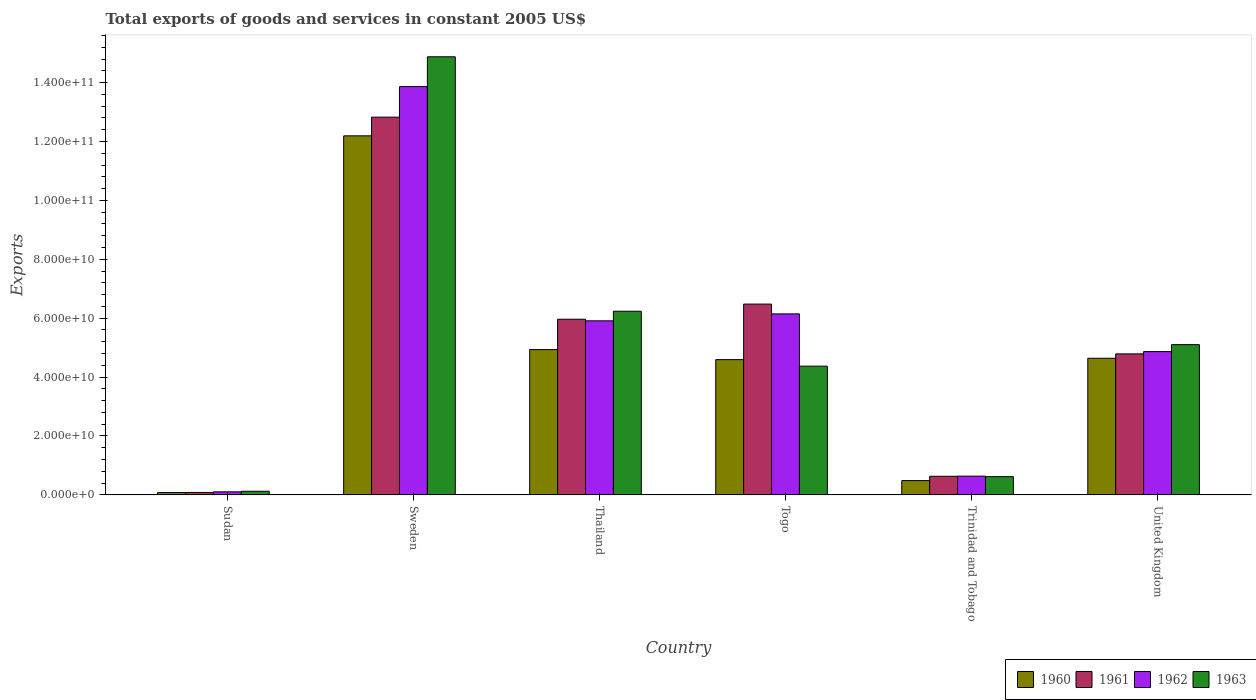How many different coloured bars are there?
Give a very brief answer. 4. Are the number of bars per tick equal to the number of legend labels?
Your answer should be compact. Yes. What is the label of the 5th group of bars from the left?
Your response must be concise. Trinidad and Tobago. What is the total exports of goods and services in 1962 in United Kingdom?
Provide a succinct answer. 4.87e+1. Across all countries, what is the maximum total exports of goods and services in 1962?
Provide a succinct answer. 1.39e+11. Across all countries, what is the minimum total exports of goods and services in 1961?
Ensure brevity in your answer.  8.33e+08. In which country was the total exports of goods and services in 1963 maximum?
Offer a very short reply. Sweden. In which country was the total exports of goods and services in 1963 minimum?
Keep it short and to the point. Sudan. What is the total total exports of goods and services in 1962 in the graph?
Give a very brief answer. 3.15e+11. What is the difference between the total exports of goods and services in 1962 in Thailand and that in Togo?
Your response must be concise. -2.36e+09. What is the difference between the total exports of goods and services in 1963 in Togo and the total exports of goods and services in 1960 in Trinidad and Tobago?
Your answer should be very brief. 3.88e+1. What is the average total exports of goods and services in 1963 per country?
Keep it short and to the point. 5.22e+1. What is the difference between the total exports of goods and services of/in 1963 and total exports of goods and services of/in 1961 in Togo?
Make the answer very short. -2.11e+1. What is the ratio of the total exports of goods and services in 1963 in Sudan to that in United Kingdom?
Your response must be concise. 0.02. Is the total exports of goods and services in 1962 in Thailand less than that in United Kingdom?
Your answer should be compact. No. Is the difference between the total exports of goods and services in 1963 in Thailand and Trinidad and Tobago greater than the difference between the total exports of goods and services in 1961 in Thailand and Trinidad and Tobago?
Your response must be concise. Yes. What is the difference between the highest and the second highest total exports of goods and services in 1960?
Offer a terse response. 2.95e+09. What is the difference between the highest and the lowest total exports of goods and services in 1963?
Give a very brief answer. 1.48e+11. In how many countries, is the total exports of goods and services in 1961 greater than the average total exports of goods and services in 1961 taken over all countries?
Provide a short and direct response. 3. Is the sum of the total exports of goods and services in 1961 in Thailand and Togo greater than the maximum total exports of goods and services in 1963 across all countries?
Your answer should be compact. No. Is it the case that in every country, the sum of the total exports of goods and services in 1961 and total exports of goods and services in 1960 is greater than the sum of total exports of goods and services in 1963 and total exports of goods and services in 1962?
Your answer should be very brief. No. What does the 1st bar from the left in United Kingdom represents?
Offer a very short reply. 1960. What does the 2nd bar from the right in Trinidad and Tobago represents?
Make the answer very short. 1962. How many bars are there?
Give a very brief answer. 24. Are all the bars in the graph horizontal?
Offer a very short reply. No. Does the graph contain any zero values?
Provide a short and direct response. No. Where does the legend appear in the graph?
Your answer should be very brief. Bottom right. How many legend labels are there?
Offer a terse response. 4. What is the title of the graph?
Provide a short and direct response. Total exports of goods and services in constant 2005 US$. What is the label or title of the X-axis?
Your response must be concise. Country. What is the label or title of the Y-axis?
Ensure brevity in your answer.  Exports. What is the Exports in 1960 in Sudan?
Your answer should be very brief. 8.03e+08. What is the Exports of 1961 in Sudan?
Your answer should be compact. 8.33e+08. What is the Exports in 1962 in Sudan?
Make the answer very short. 1.04e+09. What is the Exports of 1963 in Sudan?
Make the answer very short. 1.24e+09. What is the Exports in 1960 in Sweden?
Provide a succinct answer. 1.22e+11. What is the Exports of 1961 in Sweden?
Ensure brevity in your answer.  1.28e+11. What is the Exports in 1962 in Sweden?
Provide a succinct answer. 1.39e+11. What is the Exports in 1963 in Sweden?
Your answer should be very brief. 1.49e+11. What is the Exports of 1960 in Thailand?
Give a very brief answer. 4.93e+1. What is the Exports in 1961 in Thailand?
Give a very brief answer. 5.97e+1. What is the Exports in 1962 in Thailand?
Provide a short and direct response. 5.91e+1. What is the Exports of 1963 in Thailand?
Make the answer very short. 6.24e+1. What is the Exports in 1960 in Togo?
Ensure brevity in your answer.  4.59e+1. What is the Exports of 1961 in Togo?
Provide a succinct answer. 6.48e+1. What is the Exports of 1962 in Togo?
Your answer should be very brief. 6.15e+1. What is the Exports in 1963 in Togo?
Your answer should be compact. 4.37e+1. What is the Exports in 1960 in Trinidad and Tobago?
Provide a succinct answer. 4.86e+09. What is the Exports in 1961 in Trinidad and Tobago?
Your answer should be very brief. 6.32e+09. What is the Exports in 1962 in Trinidad and Tobago?
Your answer should be very brief. 6.37e+09. What is the Exports of 1963 in Trinidad and Tobago?
Ensure brevity in your answer.  6.20e+09. What is the Exports in 1960 in United Kingdom?
Provide a succinct answer. 4.64e+1. What is the Exports of 1961 in United Kingdom?
Provide a succinct answer. 4.79e+1. What is the Exports in 1962 in United Kingdom?
Offer a terse response. 4.87e+1. What is the Exports of 1963 in United Kingdom?
Provide a succinct answer. 5.10e+1. Across all countries, what is the maximum Exports of 1960?
Offer a very short reply. 1.22e+11. Across all countries, what is the maximum Exports of 1961?
Provide a succinct answer. 1.28e+11. Across all countries, what is the maximum Exports of 1962?
Your response must be concise. 1.39e+11. Across all countries, what is the maximum Exports of 1963?
Give a very brief answer. 1.49e+11. Across all countries, what is the minimum Exports in 1960?
Give a very brief answer. 8.03e+08. Across all countries, what is the minimum Exports of 1961?
Offer a terse response. 8.33e+08. Across all countries, what is the minimum Exports of 1962?
Offer a terse response. 1.04e+09. Across all countries, what is the minimum Exports of 1963?
Ensure brevity in your answer.  1.24e+09. What is the total Exports in 1960 in the graph?
Make the answer very short. 2.69e+11. What is the total Exports in 1961 in the graph?
Make the answer very short. 3.08e+11. What is the total Exports in 1962 in the graph?
Offer a terse response. 3.15e+11. What is the total Exports in 1963 in the graph?
Keep it short and to the point. 3.13e+11. What is the difference between the Exports of 1960 in Sudan and that in Sweden?
Your answer should be very brief. -1.21e+11. What is the difference between the Exports in 1961 in Sudan and that in Sweden?
Provide a succinct answer. -1.27e+11. What is the difference between the Exports in 1962 in Sudan and that in Sweden?
Your answer should be very brief. -1.38e+11. What is the difference between the Exports of 1963 in Sudan and that in Sweden?
Provide a short and direct response. -1.48e+11. What is the difference between the Exports in 1960 in Sudan and that in Thailand?
Your answer should be very brief. -4.85e+1. What is the difference between the Exports of 1961 in Sudan and that in Thailand?
Your answer should be very brief. -5.88e+1. What is the difference between the Exports in 1962 in Sudan and that in Thailand?
Your answer should be very brief. -5.81e+1. What is the difference between the Exports of 1963 in Sudan and that in Thailand?
Provide a succinct answer. -6.11e+1. What is the difference between the Exports in 1960 in Sudan and that in Togo?
Make the answer very short. -4.51e+1. What is the difference between the Exports of 1961 in Sudan and that in Togo?
Give a very brief answer. -6.40e+1. What is the difference between the Exports in 1962 in Sudan and that in Togo?
Your answer should be very brief. -6.04e+1. What is the difference between the Exports of 1963 in Sudan and that in Togo?
Offer a very short reply. -4.25e+1. What is the difference between the Exports in 1960 in Sudan and that in Trinidad and Tobago?
Give a very brief answer. -4.06e+09. What is the difference between the Exports in 1961 in Sudan and that in Trinidad and Tobago?
Provide a succinct answer. -5.49e+09. What is the difference between the Exports of 1962 in Sudan and that in Trinidad and Tobago?
Offer a very short reply. -5.33e+09. What is the difference between the Exports of 1963 in Sudan and that in Trinidad and Tobago?
Your answer should be very brief. -4.97e+09. What is the difference between the Exports in 1960 in Sudan and that in United Kingdom?
Your answer should be compact. -4.56e+1. What is the difference between the Exports of 1961 in Sudan and that in United Kingdom?
Provide a succinct answer. -4.71e+1. What is the difference between the Exports of 1962 in Sudan and that in United Kingdom?
Provide a short and direct response. -4.76e+1. What is the difference between the Exports of 1963 in Sudan and that in United Kingdom?
Your answer should be very brief. -4.98e+1. What is the difference between the Exports in 1960 in Sweden and that in Thailand?
Keep it short and to the point. 7.26e+1. What is the difference between the Exports of 1961 in Sweden and that in Thailand?
Provide a succinct answer. 6.86e+1. What is the difference between the Exports in 1962 in Sweden and that in Thailand?
Make the answer very short. 7.95e+1. What is the difference between the Exports in 1963 in Sweden and that in Thailand?
Your answer should be very brief. 8.64e+1. What is the difference between the Exports in 1960 in Sweden and that in Togo?
Your answer should be compact. 7.60e+1. What is the difference between the Exports of 1961 in Sweden and that in Togo?
Ensure brevity in your answer.  6.35e+1. What is the difference between the Exports in 1962 in Sweden and that in Togo?
Provide a short and direct response. 7.72e+1. What is the difference between the Exports of 1963 in Sweden and that in Togo?
Your answer should be very brief. 1.05e+11. What is the difference between the Exports in 1960 in Sweden and that in Trinidad and Tobago?
Provide a succinct answer. 1.17e+11. What is the difference between the Exports in 1961 in Sweden and that in Trinidad and Tobago?
Make the answer very short. 1.22e+11. What is the difference between the Exports of 1962 in Sweden and that in Trinidad and Tobago?
Offer a terse response. 1.32e+11. What is the difference between the Exports in 1963 in Sweden and that in Trinidad and Tobago?
Give a very brief answer. 1.43e+11. What is the difference between the Exports in 1960 in Sweden and that in United Kingdom?
Offer a very short reply. 7.55e+1. What is the difference between the Exports of 1961 in Sweden and that in United Kingdom?
Give a very brief answer. 8.04e+1. What is the difference between the Exports of 1962 in Sweden and that in United Kingdom?
Your response must be concise. 9.00e+1. What is the difference between the Exports of 1963 in Sweden and that in United Kingdom?
Offer a very short reply. 9.77e+1. What is the difference between the Exports of 1960 in Thailand and that in Togo?
Give a very brief answer. 3.42e+09. What is the difference between the Exports of 1961 in Thailand and that in Togo?
Give a very brief answer. -5.14e+09. What is the difference between the Exports in 1962 in Thailand and that in Togo?
Your response must be concise. -2.36e+09. What is the difference between the Exports in 1963 in Thailand and that in Togo?
Provide a short and direct response. 1.87e+1. What is the difference between the Exports in 1960 in Thailand and that in Trinidad and Tobago?
Give a very brief answer. 4.45e+1. What is the difference between the Exports in 1961 in Thailand and that in Trinidad and Tobago?
Your answer should be compact. 5.33e+1. What is the difference between the Exports of 1962 in Thailand and that in Trinidad and Tobago?
Provide a short and direct response. 5.27e+1. What is the difference between the Exports of 1963 in Thailand and that in Trinidad and Tobago?
Provide a short and direct response. 5.62e+1. What is the difference between the Exports in 1960 in Thailand and that in United Kingdom?
Ensure brevity in your answer.  2.95e+09. What is the difference between the Exports of 1961 in Thailand and that in United Kingdom?
Keep it short and to the point. 1.18e+1. What is the difference between the Exports of 1962 in Thailand and that in United Kingdom?
Offer a very short reply. 1.04e+1. What is the difference between the Exports in 1963 in Thailand and that in United Kingdom?
Give a very brief answer. 1.13e+1. What is the difference between the Exports in 1960 in Togo and that in Trinidad and Tobago?
Offer a terse response. 4.11e+1. What is the difference between the Exports in 1961 in Togo and that in Trinidad and Tobago?
Ensure brevity in your answer.  5.85e+1. What is the difference between the Exports of 1962 in Togo and that in Trinidad and Tobago?
Your answer should be compact. 5.51e+1. What is the difference between the Exports in 1963 in Togo and that in Trinidad and Tobago?
Give a very brief answer. 3.75e+1. What is the difference between the Exports in 1960 in Togo and that in United Kingdom?
Your answer should be very brief. -4.64e+08. What is the difference between the Exports of 1961 in Togo and that in United Kingdom?
Your answer should be compact. 1.69e+1. What is the difference between the Exports of 1962 in Togo and that in United Kingdom?
Provide a short and direct response. 1.28e+1. What is the difference between the Exports in 1963 in Togo and that in United Kingdom?
Provide a succinct answer. -7.31e+09. What is the difference between the Exports of 1960 in Trinidad and Tobago and that in United Kingdom?
Give a very brief answer. -4.15e+1. What is the difference between the Exports in 1961 in Trinidad and Tobago and that in United Kingdom?
Provide a succinct answer. -4.16e+1. What is the difference between the Exports in 1962 in Trinidad and Tobago and that in United Kingdom?
Ensure brevity in your answer.  -4.23e+1. What is the difference between the Exports of 1963 in Trinidad and Tobago and that in United Kingdom?
Offer a very short reply. -4.48e+1. What is the difference between the Exports in 1960 in Sudan and the Exports in 1961 in Sweden?
Your answer should be compact. -1.27e+11. What is the difference between the Exports in 1960 in Sudan and the Exports in 1962 in Sweden?
Give a very brief answer. -1.38e+11. What is the difference between the Exports of 1960 in Sudan and the Exports of 1963 in Sweden?
Give a very brief answer. -1.48e+11. What is the difference between the Exports in 1961 in Sudan and the Exports in 1962 in Sweden?
Your answer should be compact. -1.38e+11. What is the difference between the Exports in 1961 in Sudan and the Exports in 1963 in Sweden?
Ensure brevity in your answer.  -1.48e+11. What is the difference between the Exports of 1962 in Sudan and the Exports of 1963 in Sweden?
Your response must be concise. -1.48e+11. What is the difference between the Exports in 1960 in Sudan and the Exports in 1961 in Thailand?
Your answer should be compact. -5.88e+1. What is the difference between the Exports of 1960 in Sudan and the Exports of 1962 in Thailand?
Provide a succinct answer. -5.83e+1. What is the difference between the Exports of 1960 in Sudan and the Exports of 1963 in Thailand?
Your answer should be very brief. -6.16e+1. What is the difference between the Exports of 1961 in Sudan and the Exports of 1962 in Thailand?
Give a very brief answer. -5.83e+1. What is the difference between the Exports of 1961 in Sudan and the Exports of 1963 in Thailand?
Offer a terse response. -6.15e+1. What is the difference between the Exports of 1962 in Sudan and the Exports of 1963 in Thailand?
Make the answer very short. -6.13e+1. What is the difference between the Exports of 1960 in Sudan and the Exports of 1961 in Togo?
Your answer should be compact. -6.40e+1. What is the difference between the Exports of 1960 in Sudan and the Exports of 1962 in Togo?
Offer a terse response. -6.07e+1. What is the difference between the Exports in 1960 in Sudan and the Exports in 1963 in Togo?
Your answer should be very brief. -4.29e+1. What is the difference between the Exports of 1961 in Sudan and the Exports of 1962 in Togo?
Provide a short and direct response. -6.06e+1. What is the difference between the Exports of 1961 in Sudan and the Exports of 1963 in Togo?
Provide a succinct answer. -4.29e+1. What is the difference between the Exports in 1962 in Sudan and the Exports in 1963 in Togo?
Keep it short and to the point. -4.27e+1. What is the difference between the Exports of 1960 in Sudan and the Exports of 1961 in Trinidad and Tobago?
Ensure brevity in your answer.  -5.52e+09. What is the difference between the Exports in 1960 in Sudan and the Exports in 1962 in Trinidad and Tobago?
Give a very brief answer. -5.57e+09. What is the difference between the Exports of 1960 in Sudan and the Exports of 1963 in Trinidad and Tobago?
Keep it short and to the point. -5.40e+09. What is the difference between the Exports of 1961 in Sudan and the Exports of 1962 in Trinidad and Tobago?
Provide a short and direct response. -5.54e+09. What is the difference between the Exports of 1961 in Sudan and the Exports of 1963 in Trinidad and Tobago?
Offer a terse response. -5.37e+09. What is the difference between the Exports in 1962 in Sudan and the Exports in 1963 in Trinidad and Tobago?
Give a very brief answer. -5.16e+09. What is the difference between the Exports in 1960 in Sudan and the Exports in 1961 in United Kingdom?
Offer a very short reply. -4.71e+1. What is the difference between the Exports of 1960 in Sudan and the Exports of 1962 in United Kingdom?
Ensure brevity in your answer.  -4.79e+1. What is the difference between the Exports in 1960 in Sudan and the Exports in 1963 in United Kingdom?
Offer a very short reply. -5.02e+1. What is the difference between the Exports of 1961 in Sudan and the Exports of 1962 in United Kingdom?
Ensure brevity in your answer.  -4.78e+1. What is the difference between the Exports in 1961 in Sudan and the Exports in 1963 in United Kingdom?
Offer a very short reply. -5.02e+1. What is the difference between the Exports of 1962 in Sudan and the Exports of 1963 in United Kingdom?
Your answer should be compact. -5.00e+1. What is the difference between the Exports of 1960 in Sweden and the Exports of 1961 in Thailand?
Make the answer very short. 6.23e+1. What is the difference between the Exports of 1960 in Sweden and the Exports of 1962 in Thailand?
Offer a terse response. 6.28e+1. What is the difference between the Exports of 1960 in Sweden and the Exports of 1963 in Thailand?
Provide a succinct answer. 5.96e+1. What is the difference between the Exports of 1961 in Sweden and the Exports of 1962 in Thailand?
Make the answer very short. 6.92e+1. What is the difference between the Exports of 1961 in Sweden and the Exports of 1963 in Thailand?
Give a very brief answer. 6.59e+1. What is the difference between the Exports in 1962 in Sweden and the Exports in 1963 in Thailand?
Keep it short and to the point. 7.63e+1. What is the difference between the Exports of 1960 in Sweden and the Exports of 1961 in Togo?
Offer a very short reply. 5.71e+1. What is the difference between the Exports in 1960 in Sweden and the Exports in 1962 in Togo?
Your response must be concise. 6.05e+1. What is the difference between the Exports in 1960 in Sweden and the Exports in 1963 in Togo?
Ensure brevity in your answer.  7.82e+1. What is the difference between the Exports of 1961 in Sweden and the Exports of 1962 in Togo?
Your response must be concise. 6.68e+1. What is the difference between the Exports of 1961 in Sweden and the Exports of 1963 in Togo?
Offer a very short reply. 8.46e+1. What is the difference between the Exports in 1962 in Sweden and the Exports in 1963 in Togo?
Make the answer very short. 9.49e+1. What is the difference between the Exports in 1960 in Sweden and the Exports in 1961 in Trinidad and Tobago?
Provide a short and direct response. 1.16e+11. What is the difference between the Exports of 1960 in Sweden and the Exports of 1962 in Trinidad and Tobago?
Your response must be concise. 1.16e+11. What is the difference between the Exports in 1960 in Sweden and the Exports in 1963 in Trinidad and Tobago?
Offer a terse response. 1.16e+11. What is the difference between the Exports in 1961 in Sweden and the Exports in 1962 in Trinidad and Tobago?
Your response must be concise. 1.22e+11. What is the difference between the Exports of 1961 in Sweden and the Exports of 1963 in Trinidad and Tobago?
Offer a terse response. 1.22e+11. What is the difference between the Exports of 1962 in Sweden and the Exports of 1963 in Trinidad and Tobago?
Offer a terse response. 1.32e+11. What is the difference between the Exports of 1960 in Sweden and the Exports of 1961 in United Kingdom?
Your answer should be compact. 7.40e+1. What is the difference between the Exports of 1960 in Sweden and the Exports of 1962 in United Kingdom?
Offer a very short reply. 7.33e+1. What is the difference between the Exports of 1960 in Sweden and the Exports of 1963 in United Kingdom?
Provide a short and direct response. 7.09e+1. What is the difference between the Exports of 1961 in Sweden and the Exports of 1962 in United Kingdom?
Give a very brief answer. 7.96e+1. What is the difference between the Exports in 1961 in Sweden and the Exports in 1963 in United Kingdom?
Give a very brief answer. 7.72e+1. What is the difference between the Exports in 1962 in Sweden and the Exports in 1963 in United Kingdom?
Ensure brevity in your answer.  8.76e+1. What is the difference between the Exports of 1960 in Thailand and the Exports of 1961 in Togo?
Provide a succinct answer. -1.54e+1. What is the difference between the Exports of 1960 in Thailand and the Exports of 1962 in Togo?
Your response must be concise. -1.21e+1. What is the difference between the Exports in 1960 in Thailand and the Exports in 1963 in Togo?
Give a very brief answer. 5.64e+09. What is the difference between the Exports in 1961 in Thailand and the Exports in 1962 in Togo?
Keep it short and to the point. -1.81e+09. What is the difference between the Exports in 1961 in Thailand and the Exports in 1963 in Togo?
Give a very brief answer. 1.59e+1. What is the difference between the Exports in 1962 in Thailand and the Exports in 1963 in Togo?
Keep it short and to the point. 1.54e+1. What is the difference between the Exports of 1960 in Thailand and the Exports of 1961 in Trinidad and Tobago?
Your answer should be very brief. 4.30e+1. What is the difference between the Exports in 1960 in Thailand and the Exports in 1962 in Trinidad and Tobago?
Your response must be concise. 4.30e+1. What is the difference between the Exports in 1960 in Thailand and the Exports in 1963 in Trinidad and Tobago?
Offer a terse response. 4.31e+1. What is the difference between the Exports in 1961 in Thailand and the Exports in 1962 in Trinidad and Tobago?
Your response must be concise. 5.33e+1. What is the difference between the Exports of 1961 in Thailand and the Exports of 1963 in Trinidad and Tobago?
Offer a very short reply. 5.34e+1. What is the difference between the Exports in 1962 in Thailand and the Exports in 1963 in Trinidad and Tobago?
Provide a short and direct response. 5.29e+1. What is the difference between the Exports in 1960 in Thailand and the Exports in 1961 in United Kingdom?
Offer a very short reply. 1.46e+09. What is the difference between the Exports in 1960 in Thailand and the Exports in 1962 in United Kingdom?
Your answer should be very brief. 6.85e+08. What is the difference between the Exports in 1960 in Thailand and the Exports in 1963 in United Kingdom?
Your response must be concise. -1.67e+09. What is the difference between the Exports in 1961 in Thailand and the Exports in 1962 in United Kingdom?
Provide a succinct answer. 1.10e+1. What is the difference between the Exports of 1961 in Thailand and the Exports of 1963 in United Kingdom?
Ensure brevity in your answer.  8.63e+09. What is the difference between the Exports in 1962 in Thailand and the Exports in 1963 in United Kingdom?
Offer a very short reply. 8.09e+09. What is the difference between the Exports of 1960 in Togo and the Exports of 1961 in Trinidad and Tobago?
Provide a succinct answer. 3.96e+1. What is the difference between the Exports in 1960 in Togo and the Exports in 1962 in Trinidad and Tobago?
Ensure brevity in your answer.  3.96e+1. What is the difference between the Exports in 1960 in Togo and the Exports in 1963 in Trinidad and Tobago?
Ensure brevity in your answer.  3.97e+1. What is the difference between the Exports of 1961 in Togo and the Exports of 1962 in Trinidad and Tobago?
Your response must be concise. 5.84e+1. What is the difference between the Exports in 1961 in Togo and the Exports in 1963 in Trinidad and Tobago?
Give a very brief answer. 5.86e+1. What is the difference between the Exports of 1962 in Togo and the Exports of 1963 in Trinidad and Tobago?
Ensure brevity in your answer.  5.53e+1. What is the difference between the Exports in 1960 in Togo and the Exports in 1961 in United Kingdom?
Your answer should be very brief. -1.96e+09. What is the difference between the Exports in 1960 in Togo and the Exports in 1962 in United Kingdom?
Keep it short and to the point. -2.73e+09. What is the difference between the Exports of 1960 in Togo and the Exports of 1963 in United Kingdom?
Provide a short and direct response. -5.09e+09. What is the difference between the Exports in 1961 in Togo and the Exports in 1962 in United Kingdom?
Provide a short and direct response. 1.61e+1. What is the difference between the Exports in 1961 in Togo and the Exports in 1963 in United Kingdom?
Make the answer very short. 1.38e+1. What is the difference between the Exports in 1962 in Togo and the Exports in 1963 in United Kingdom?
Your answer should be very brief. 1.04e+1. What is the difference between the Exports in 1960 in Trinidad and Tobago and the Exports in 1961 in United Kingdom?
Your answer should be compact. -4.30e+1. What is the difference between the Exports of 1960 in Trinidad and Tobago and the Exports of 1962 in United Kingdom?
Your answer should be compact. -4.38e+1. What is the difference between the Exports in 1960 in Trinidad and Tobago and the Exports in 1963 in United Kingdom?
Provide a short and direct response. -4.62e+1. What is the difference between the Exports in 1961 in Trinidad and Tobago and the Exports in 1962 in United Kingdom?
Provide a short and direct response. -4.23e+1. What is the difference between the Exports of 1961 in Trinidad and Tobago and the Exports of 1963 in United Kingdom?
Offer a terse response. -4.47e+1. What is the difference between the Exports of 1962 in Trinidad and Tobago and the Exports of 1963 in United Kingdom?
Give a very brief answer. -4.47e+1. What is the average Exports in 1960 per country?
Offer a very short reply. 4.49e+1. What is the average Exports in 1961 per country?
Give a very brief answer. 5.13e+1. What is the average Exports of 1962 per country?
Ensure brevity in your answer.  5.25e+1. What is the average Exports of 1963 per country?
Provide a short and direct response. 5.22e+1. What is the difference between the Exports in 1960 and Exports in 1961 in Sudan?
Keep it short and to the point. -3.01e+07. What is the difference between the Exports in 1960 and Exports in 1962 in Sudan?
Make the answer very short. -2.41e+08. What is the difference between the Exports of 1960 and Exports of 1963 in Sudan?
Your answer should be very brief. -4.34e+08. What is the difference between the Exports in 1961 and Exports in 1962 in Sudan?
Your answer should be compact. -2.11e+08. What is the difference between the Exports of 1961 and Exports of 1963 in Sudan?
Make the answer very short. -4.04e+08. What is the difference between the Exports in 1962 and Exports in 1963 in Sudan?
Give a very brief answer. -1.93e+08. What is the difference between the Exports of 1960 and Exports of 1961 in Sweden?
Your answer should be compact. -6.34e+09. What is the difference between the Exports in 1960 and Exports in 1962 in Sweden?
Your response must be concise. -1.67e+1. What is the difference between the Exports in 1960 and Exports in 1963 in Sweden?
Keep it short and to the point. -2.68e+1. What is the difference between the Exports in 1961 and Exports in 1962 in Sweden?
Your response must be concise. -1.04e+1. What is the difference between the Exports in 1961 and Exports in 1963 in Sweden?
Offer a terse response. -2.05e+1. What is the difference between the Exports of 1962 and Exports of 1963 in Sweden?
Your answer should be very brief. -1.01e+1. What is the difference between the Exports of 1960 and Exports of 1961 in Thailand?
Your response must be concise. -1.03e+1. What is the difference between the Exports in 1960 and Exports in 1962 in Thailand?
Provide a short and direct response. -9.76e+09. What is the difference between the Exports in 1960 and Exports in 1963 in Thailand?
Offer a terse response. -1.30e+1. What is the difference between the Exports in 1961 and Exports in 1962 in Thailand?
Provide a short and direct response. 5.43e+08. What is the difference between the Exports in 1961 and Exports in 1963 in Thailand?
Offer a terse response. -2.71e+09. What is the difference between the Exports of 1962 and Exports of 1963 in Thailand?
Your response must be concise. -3.25e+09. What is the difference between the Exports of 1960 and Exports of 1961 in Togo?
Offer a terse response. -1.89e+1. What is the difference between the Exports in 1960 and Exports in 1962 in Togo?
Offer a terse response. -1.55e+1. What is the difference between the Exports of 1960 and Exports of 1963 in Togo?
Make the answer very short. 2.22e+09. What is the difference between the Exports of 1961 and Exports of 1962 in Togo?
Offer a very short reply. 3.33e+09. What is the difference between the Exports of 1961 and Exports of 1963 in Togo?
Your answer should be very brief. 2.11e+1. What is the difference between the Exports of 1962 and Exports of 1963 in Togo?
Provide a succinct answer. 1.78e+1. What is the difference between the Exports in 1960 and Exports in 1961 in Trinidad and Tobago?
Offer a terse response. -1.46e+09. What is the difference between the Exports in 1960 and Exports in 1962 in Trinidad and Tobago?
Offer a terse response. -1.51e+09. What is the difference between the Exports of 1960 and Exports of 1963 in Trinidad and Tobago?
Offer a terse response. -1.34e+09. What is the difference between the Exports of 1961 and Exports of 1962 in Trinidad and Tobago?
Your answer should be very brief. -4.56e+07. What is the difference between the Exports of 1961 and Exports of 1963 in Trinidad and Tobago?
Your answer should be very brief. 1.22e+08. What is the difference between the Exports in 1962 and Exports in 1963 in Trinidad and Tobago?
Offer a terse response. 1.67e+08. What is the difference between the Exports in 1960 and Exports in 1961 in United Kingdom?
Provide a short and direct response. -1.49e+09. What is the difference between the Exports of 1960 and Exports of 1962 in United Kingdom?
Offer a very short reply. -2.27e+09. What is the difference between the Exports in 1960 and Exports in 1963 in United Kingdom?
Offer a terse response. -4.63e+09. What is the difference between the Exports of 1961 and Exports of 1962 in United Kingdom?
Offer a terse response. -7.73e+08. What is the difference between the Exports in 1961 and Exports in 1963 in United Kingdom?
Provide a short and direct response. -3.13e+09. What is the difference between the Exports of 1962 and Exports of 1963 in United Kingdom?
Provide a succinct answer. -2.36e+09. What is the ratio of the Exports of 1960 in Sudan to that in Sweden?
Your response must be concise. 0.01. What is the ratio of the Exports of 1961 in Sudan to that in Sweden?
Provide a succinct answer. 0.01. What is the ratio of the Exports in 1962 in Sudan to that in Sweden?
Your response must be concise. 0.01. What is the ratio of the Exports in 1963 in Sudan to that in Sweden?
Provide a short and direct response. 0.01. What is the ratio of the Exports in 1960 in Sudan to that in Thailand?
Offer a terse response. 0.02. What is the ratio of the Exports in 1961 in Sudan to that in Thailand?
Your answer should be very brief. 0.01. What is the ratio of the Exports in 1962 in Sudan to that in Thailand?
Your answer should be compact. 0.02. What is the ratio of the Exports in 1963 in Sudan to that in Thailand?
Give a very brief answer. 0.02. What is the ratio of the Exports of 1960 in Sudan to that in Togo?
Your response must be concise. 0.02. What is the ratio of the Exports of 1961 in Sudan to that in Togo?
Offer a terse response. 0.01. What is the ratio of the Exports of 1962 in Sudan to that in Togo?
Your answer should be very brief. 0.02. What is the ratio of the Exports in 1963 in Sudan to that in Togo?
Your answer should be very brief. 0.03. What is the ratio of the Exports in 1960 in Sudan to that in Trinidad and Tobago?
Ensure brevity in your answer.  0.17. What is the ratio of the Exports in 1961 in Sudan to that in Trinidad and Tobago?
Offer a terse response. 0.13. What is the ratio of the Exports in 1962 in Sudan to that in Trinidad and Tobago?
Offer a terse response. 0.16. What is the ratio of the Exports in 1963 in Sudan to that in Trinidad and Tobago?
Provide a short and direct response. 0.2. What is the ratio of the Exports of 1960 in Sudan to that in United Kingdom?
Give a very brief answer. 0.02. What is the ratio of the Exports in 1961 in Sudan to that in United Kingdom?
Your answer should be very brief. 0.02. What is the ratio of the Exports in 1962 in Sudan to that in United Kingdom?
Offer a terse response. 0.02. What is the ratio of the Exports in 1963 in Sudan to that in United Kingdom?
Your response must be concise. 0.02. What is the ratio of the Exports in 1960 in Sweden to that in Thailand?
Provide a succinct answer. 2.47. What is the ratio of the Exports of 1961 in Sweden to that in Thailand?
Give a very brief answer. 2.15. What is the ratio of the Exports of 1962 in Sweden to that in Thailand?
Make the answer very short. 2.35. What is the ratio of the Exports in 1963 in Sweden to that in Thailand?
Offer a terse response. 2.39. What is the ratio of the Exports of 1960 in Sweden to that in Togo?
Make the answer very short. 2.65. What is the ratio of the Exports in 1961 in Sweden to that in Togo?
Make the answer very short. 1.98. What is the ratio of the Exports in 1962 in Sweden to that in Togo?
Your response must be concise. 2.26. What is the ratio of the Exports of 1963 in Sweden to that in Togo?
Provide a short and direct response. 3.4. What is the ratio of the Exports of 1960 in Sweden to that in Trinidad and Tobago?
Your response must be concise. 25.06. What is the ratio of the Exports in 1961 in Sweden to that in Trinidad and Tobago?
Give a very brief answer. 20.28. What is the ratio of the Exports of 1962 in Sweden to that in Trinidad and Tobago?
Your answer should be very brief. 21.77. What is the ratio of the Exports of 1963 in Sweden to that in Trinidad and Tobago?
Your response must be concise. 23.98. What is the ratio of the Exports in 1960 in Sweden to that in United Kingdom?
Your answer should be compact. 2.63. What is the ratio of the Exports in 1961 in Sweden to that in United Kingdom?
Provide a succinct answer. 2.68. What is the ratio of the Exports in 1962 in Sweden to that in United Kingdom?
Offer a terse response. 2.85. What is the ratio of the Exports in 1963 in Sweden to that in United Kingdom?
Keep it short and to the point. 2.92. What is the ratio of the Exports in 1960 in Thailand to that in Togo?
Your answer should be compact. 1.07. What is the ratio of the Exports of 1961 in Thailand to that in Togo?
Make the answer very short. 0.92. What is the ratio of the Exports of 1962 in Thailand to that in Togo?
Give a very brief answer. 0.96. What is the ratio of the Exports in 1963 in Thailand to that in Togo?
Offer a very short reply. 1.43. What is the ratio of the Exports in 1960 in Thailand to that in Trinidad and Tobago?
Your response must be concise. 10.14. What is the ratio of the Exports of 1961 in Thailand to that in Trinidad and Tobago?
Your answer should be very brief. 9.43. What is the ratio of the Exports of 1962 in Thailand to that in Trinidad and Tobago?
Make the answer very short. 9.28. What is the ratio of the Exports in 1963 in Thailand to that in Trinidad and Tobago?
Keep it short and to the point. 10.05. What is the ratio of the Exports of 1960 in Thailand to that in United Kingdom?
Keep it short and to the point. 1.06. What is the ratio of the Exports of 1961 in Thailand to that in United Kingdom?
Your response must be concise. 1.25. What is the ratio of the Exports in 1962 in Thailand to that in United Kingdom?
Ensure brevity in your answer.  1.21. What is the ratio of the Exports in 1963 in Thailand to that in United Kingdom?
Ensure brevity in your answer.  1.22. What is the ratio of the Exports of 1960 in Togo to that in Trinidad and Tobago?
Provide a succinct answer. 9.44. What is the ratio of the Exports of 1961 in Togo to that in Trinidad and Tobago?
Your answer should be compact. 10.25. What is the ratio of the Exports in 1962 in Togo to that in Trinidad and Tobago?
Your answer should be compact. 9.65. What is the ratio of the Exports of 1963 in Togo to that in Trinidad and Tobago?
Your answer should be compact. 7.05. What is the ratio of the Exports in 1961 in Togo to that in United Kingdom?
Give a very brief answer. 1.35. What is the ratio of the Exports of 1962 in Togo to that in United Kingdom?
Give a very brief answer. 1.26. What is the ratio of the Exports in 1963 in Togo to that in United Kingdom?
Make the answer very short. 0.86. What is the ratio of the Exports of 1960 in Trinidad and Tobago to that in United Kingdom?
Your answer should be compact. 0.1. What is the ratio of the Exports in 1961 in Trinidad and Tobago to that in United Kingdom?
Provide a short and direct response. 0.13. What is the ratio of the Exports of 1962 in Trinidad and Tobago to that in United Kingdom?
Provide a short and direct response. 0.13. What is the ratio of the Exports of 1963 in Trinidad and Tobago to that in United Kingdom?
Keep it short and to the point. 0.12. What is the difference between the highest and the second highest Exports in 1960?
Provide a short and direct response. 7.26e+1. What is the difference between the highest and the second highest Exports in 1961?
Ensure brevity in your answer.  6.35e+1. What is the difference between the highest and the second highest Exports of 1962?
Provide a succinct answer. 7.72e+1. What is the difference between the highest and the second highest Exports of 1963?
Your answer should be very brief. 8.64e+1. What is the difference between the highest and the lowest Exports of 1960?
Your answer should be very brief. 1.21e+11. What is the difference between the highest and the lowest Exports in 1961?
Keep it short and to the point. 1.27e+11. What is the difference between the highest and the lowest Exports in 1962?
Make the answer very short. 1.38e+11. What is the difference between the highest and the lowest Exports in 1963?
Your response must be concise. 1.48e+11. 